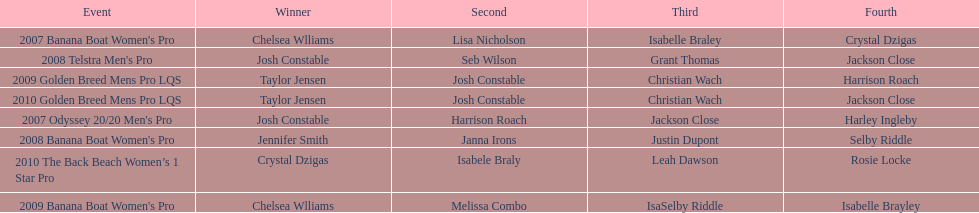How many times was josh constable the winner after 2007? 1. 